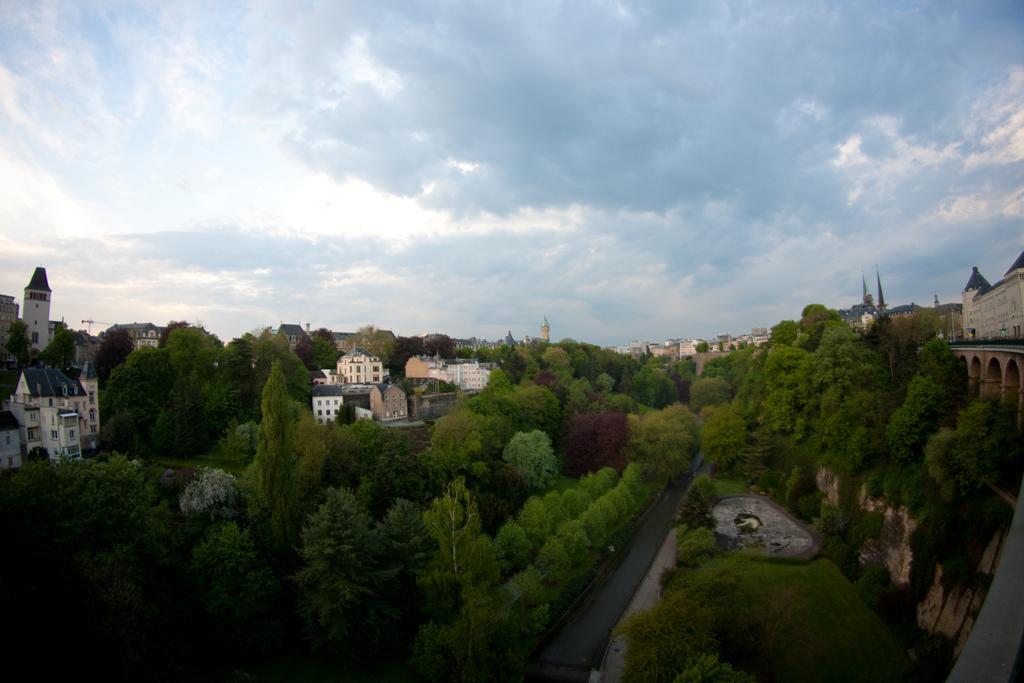Can you describe this image briefly? There are plants, trees, buildings and towers on the ground. In the background, there are clouds in the sky. 